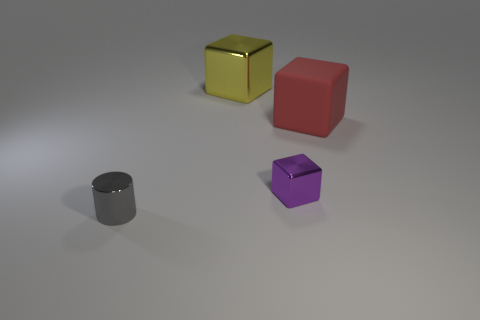Do the shapes in the image have any particular meaning or arrangement? There isn't an obvious meaning or deliberate arrangement to the shapes in the image that can be determined definitively. They seem to be randomly placed. However, one could interpret them through various lenses, such as an abstract art composition, a selection of geometric figures for educational purposes, or perhaps a minimalist display. The relative distances and positions could potentially evoke concepts of isolation or randomness when observed from an artistic perspective. 